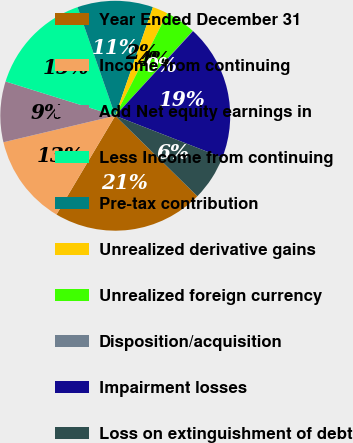Convert chart to OTSL. <chart><loc_0><loc_0><loc_500><loc_500><pie_chart><fcel>Year Ended December 31<fcel>Income from continuing<fcel>Add Net equity earnings in<fcel>Less Income from continuing<fcel>Pre-tax contribution<fcel>Unrealized derivative gains<fcel>Unrealized foreign currency<fcel>Disposition/acquisition<fcel>Impairment losses<fcel>Loss on extinguishment of debt<nl><fcel>21.21%<fcel>12.75%<fcel>8.52%<fcel>14.86%<fcel>10.63%<fcel>2.18%<fcel>4.29%<fcel>0.06%<fcel>19.09%<fcel>6.41%<nl></chart> 